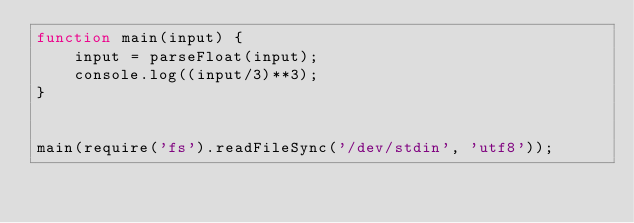<code> <loc_0><loc_0><loc_500><loc_500><_JavaScript_>function main(input) {
    input = parseFloat(input);
    console.log((input/3)**3);
}


main(require('fs').readFileSync('/dev/stdin', 'utf8'));</code> 